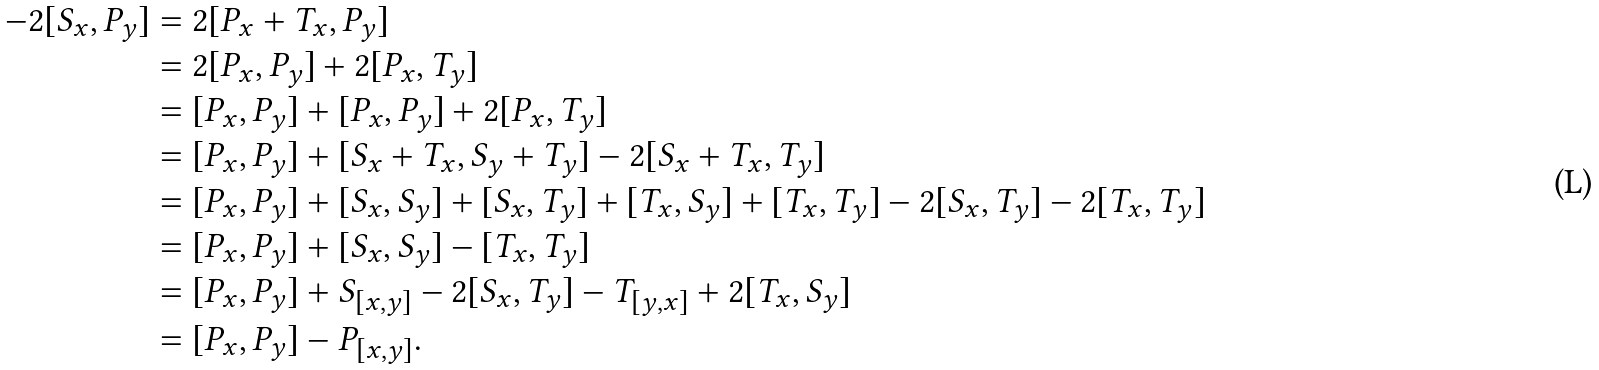Convert formula to latex. <formula><loc_0><loc_0><loc_500><loc_500>- 2 [ S _ { x } , P _ { y } ] & = 2 [ P _ { x } + T _ { x } , P _ { y } ] \\ & = 2 [ P _ { x } , P _ { y } ] + 2 [ P _ { x } , T _ { y } ] \\ & = [ P _ { x } , P _ { y } ] + [ P _ { x } , P _ { y } ] + 2 [ P _ { x } , T _ { y } ] \\ & = [ P _ { x } , P _ { y } ] + [ S _ { x } + T _ { x } , S _ { y } + T _ { y } ] - 2 [ S _ { x } + T _ { x } , T _ { y } ] \\ & = [ P _ { x } , P _ { y } ] + [ S _ { x } , S _ { y } ] + [ S _ { x } , T _ { y } ] + [ T _ { x } , S _ { y } ] + [ T _ { x } , T _ { y } ] - 2 [ S _ { x } , T _ { y } ] - 2 [ T _ { x } , T _ { y } ] \\ & = [ P _ { x } , P _ { y } ] + [ S _ { x } , S _ { y } ] - [ T _ { x } , T _ { y } ] \\ & = [ P _ { x } , P _ { y } ] + S _ { [ x , y ] } - 2 [ S _ { x } , T _ { y } ] - T _ { [ y , x ] } + 2 [ T _ { x } , S _ { y } ] \\ & = [ P _ { x } , P _ { y } ] - P _ { [ x , y ] } .</formula> 